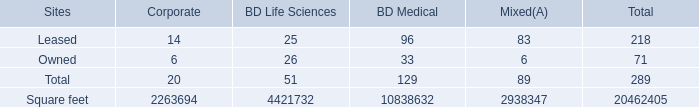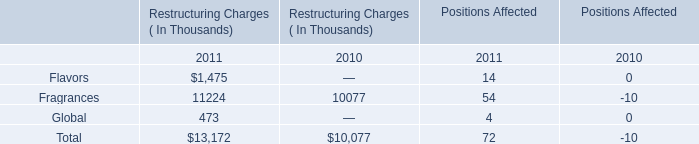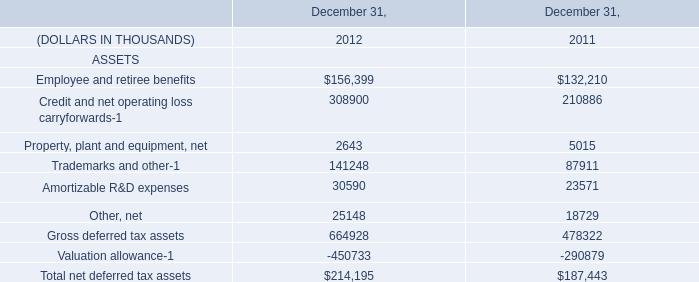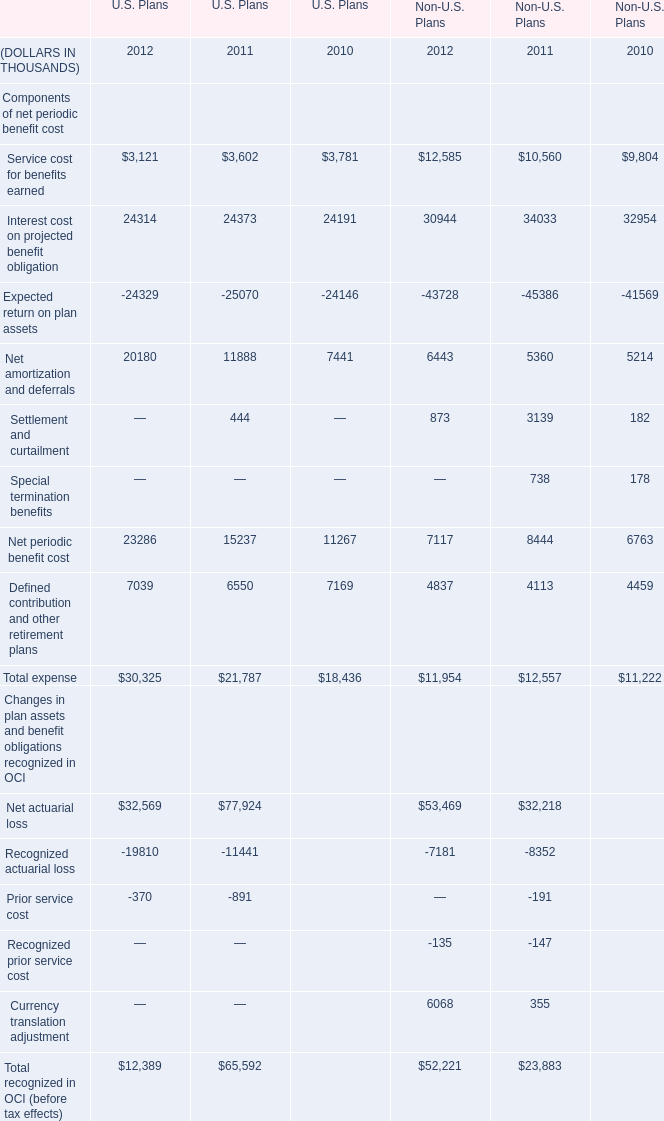What's the increasing rate of Net periodic benefit cost in terms of U.S. Plans in 2011? 
Computations: ((15237 - 11267) / 11267)
Answer: 0.35236. 